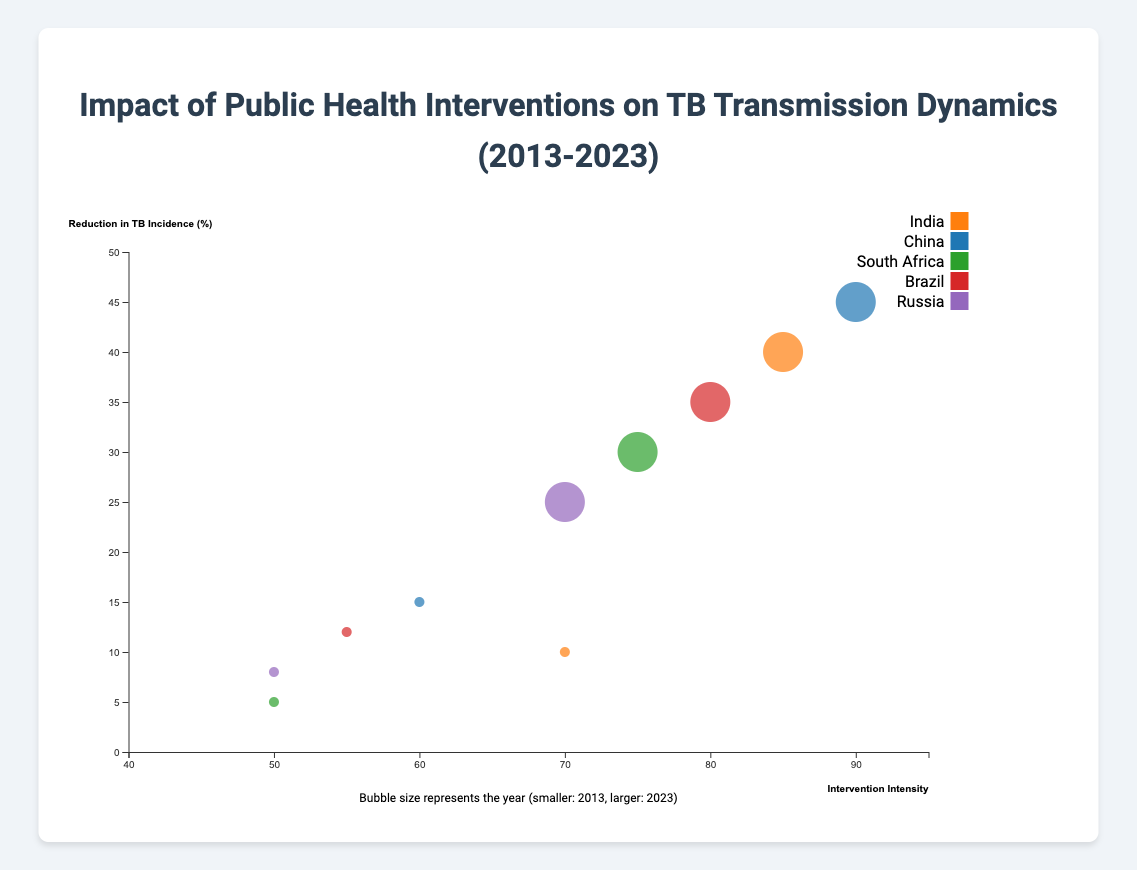What is the title of the figure? The title of the figure is displayed at the top, which reads "Impact of Public Health Interventions on TB Transmission Dynamics (2013-2023)"
Answer: Impact of Public Health Interventions on TB Transmission Dynamics (2013-2023) How many countries are compared in this figure? By counting the number of unique colors in the legend, we can deduce that there are five countries compared in the figure. The countries listed in the legend are India, China, South Africa, Brazil, and Russia
Answer: 5 Which country has the highest reduction in TB incidence in 2023? Locate the largest bubbles for 2023 (as the size is larger for 2023) and find the one positioned highest on the vertical axis (Reduction in TB Incidence). It is China with 45% reduction
Answer: China What trend can be observed in the intervention intensities from 2013 to 2023 across all countries? For all countries, the bubbles representing 2023 have shifted to the right compared to those of 2013. This implies that the intervention intensity has increased from 2013 to 2023 across all countries
Answer: Intervention intensity increased How much has TB incidence reduction improved for Brazil between 2013 and 2023? Find the bubbles for Brazil for 2013 and 2023. In 2013, TB incidence reduction was 12%, and in 2023 it was 35%. The improvement is calculated as 35% - 12% = 23%
Answer: 23% Which country had the lowest intervention intensity in 2013? Identify the leftmost bubbles corresponding to the year 2013 in the figure. South Africa, with an intervention intensity of 50, had the lowest intervention intensity in 2013
Answer: South Africa Between India and Russia, which country saw a greater improvement in TB incidence reduction from 2013 to 2023? Compare the TB incidence reduction percentages for India and Russia between 2013 and 2023. For India: 40% in 2023 - 10% in 2013 = 30%. For Russia: 25% in 2023 - 8% in 2013 = 17%. India saw a greater improvement
Answer: India What relationship can be observed between intervention intensity and reduction in TB incidence across all countries? Notice how bubbles with higher intervention intensity values (right side) are placed higher on the vertical axis, indicating a general trend that higher intervention intensity is associated with greater reduction in TB incidence
Answer: Higher intervention intensity, greater TB incidence reduction By what percentage did South Africa increase its intervention intensity from 2013 to 2023? Locate South Africa's bubbles in 2013 and 2023 on the horizontal axis. The intervention intensity in 2013 was 50 and in 2023 it was 75. The increase is calculated as 75 - 50 = 25%
Answer: 25% What is the size indicator of the bubbles, and how does it relate to the data points? The size of the bubbles represents the year, with smaller bubbles for 2013 and larger bubbles for 2023. This size difference distinguishes data points from different years
Answer: Year (smaller for 2013, larger for 2023) 